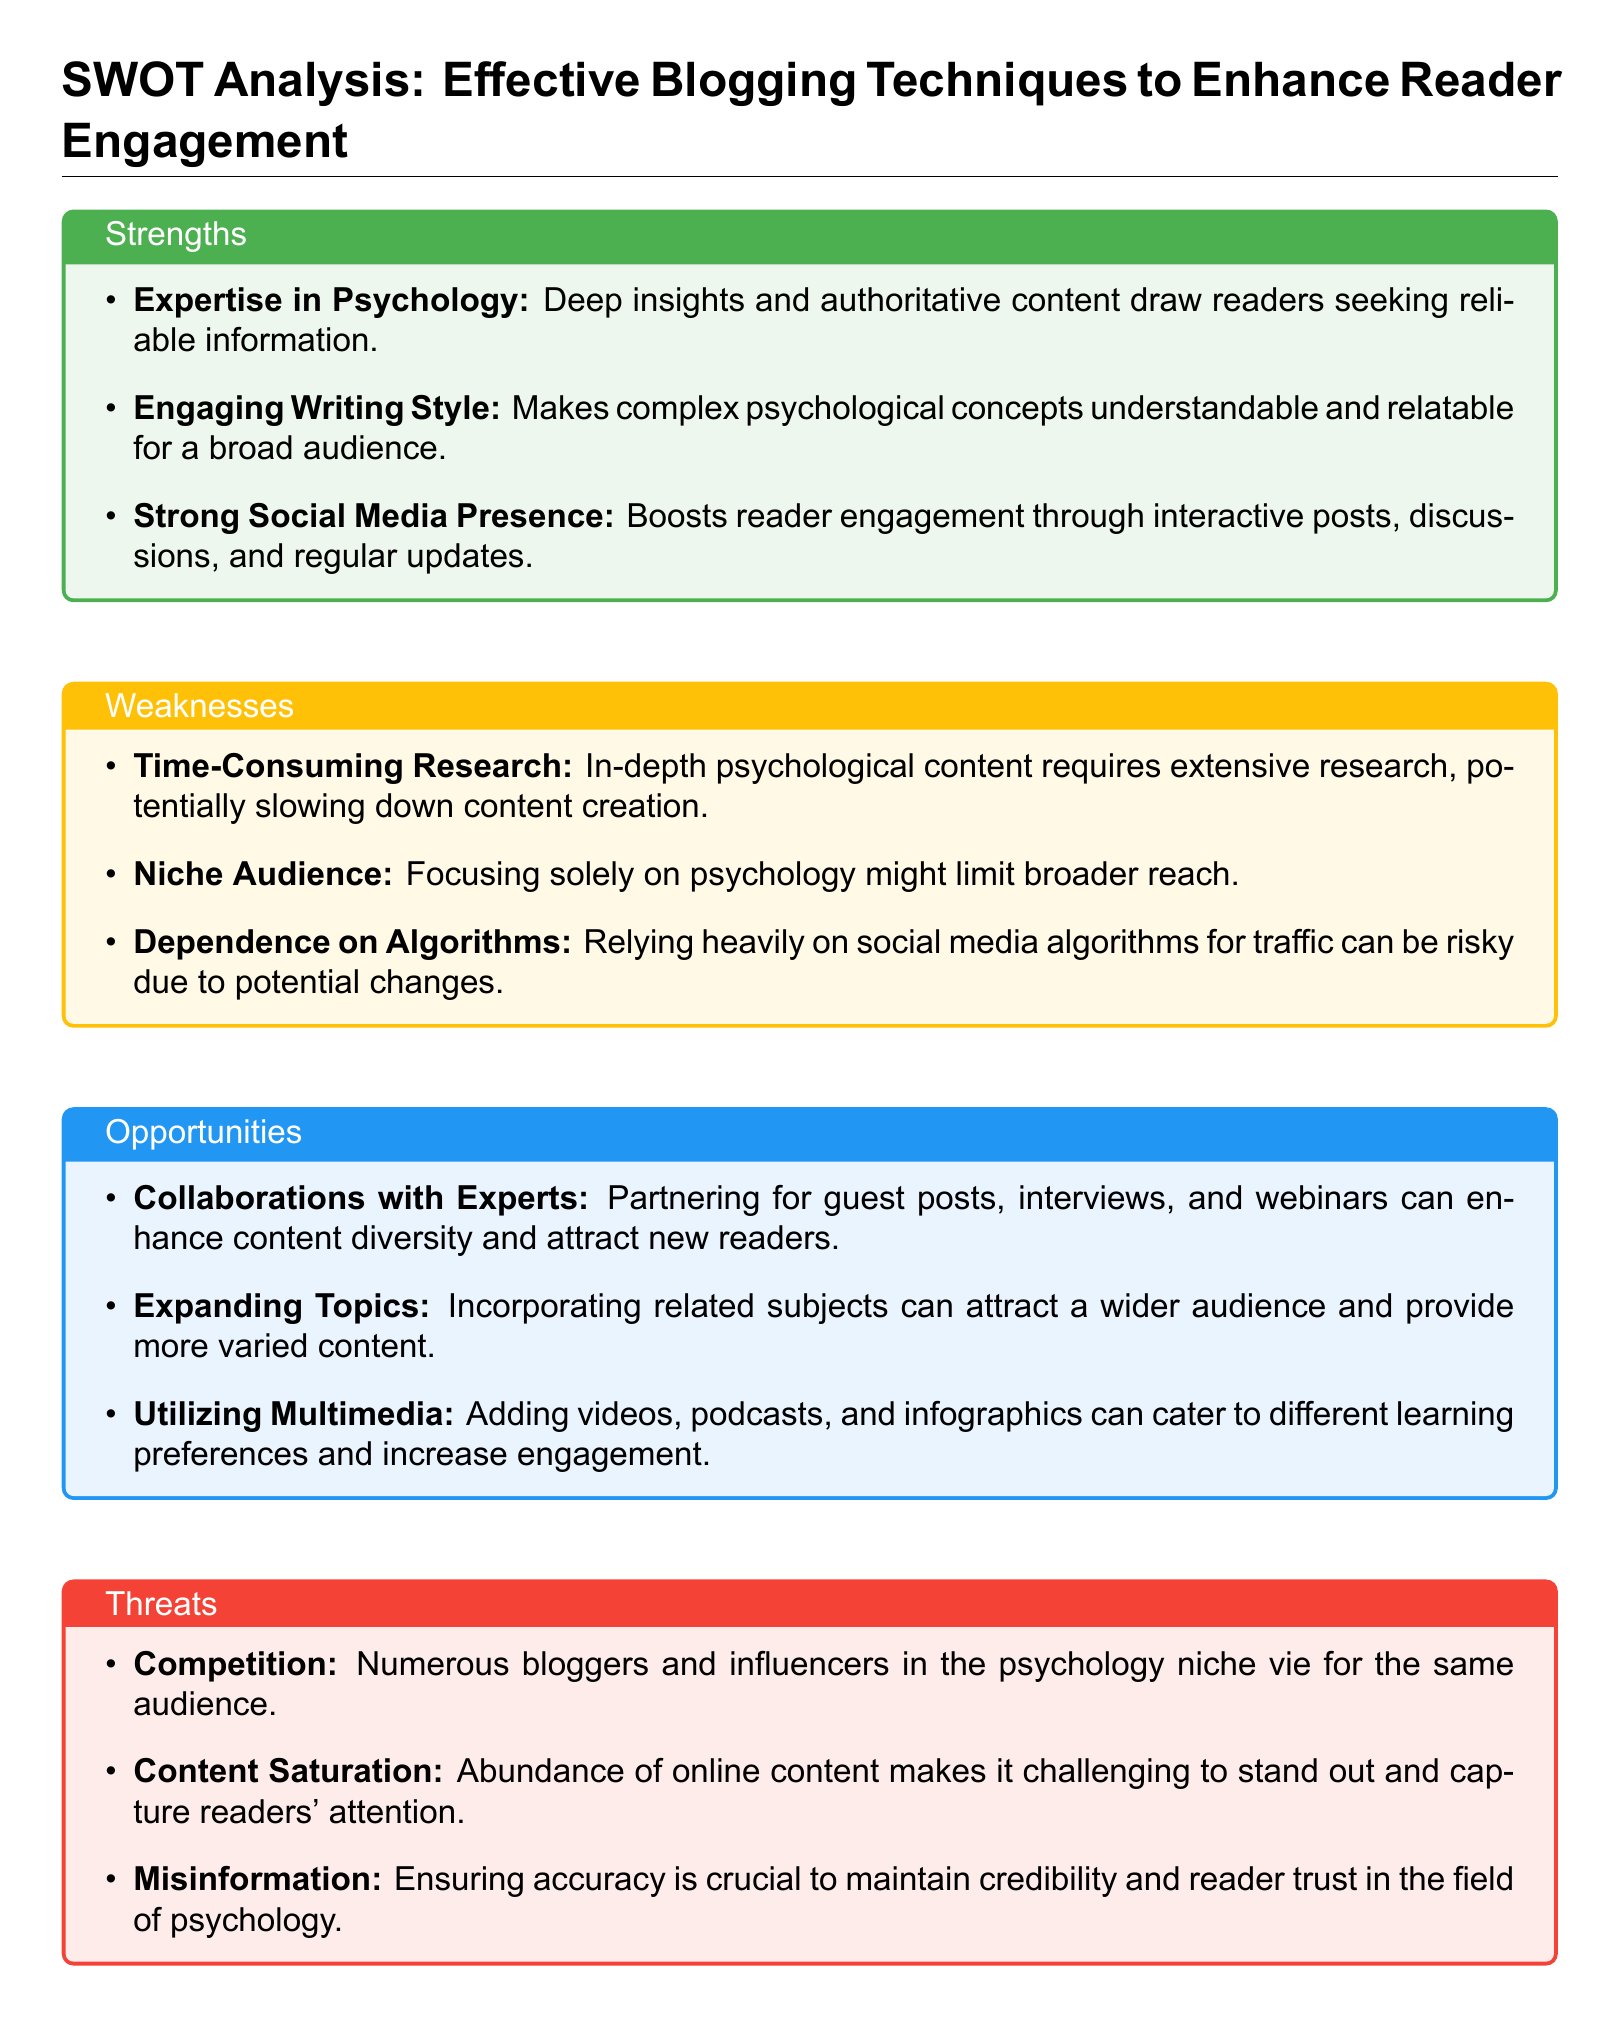What are the strengths highlighted in the document? The strengths are listed in a bullet format within the "Strengths" section of the SWOT analysis.
Answer: Expertise in Psychology, Engaging Writing Style, Strong Social Media Presence What weakness is mentioned that involves research? The weakness specifically refers to the time and effort required for research, affecting content creation.
Answer: Time-Consuming Research What opportunity involves multimedia? The opportunity discusses the potential benefits of using different media types for enhancing engagement.
Answer: Utilizing Multimedia How many threats are identified in the analysis? The document lists three distinct threats under the "Threats" section.
Answer: Three What is a specific risk mentioned related to social media? The document states that relying on social media algorithms poses a risk.
Answer: Dependence on Algorithms Which opportunity can help attract new readers through collaboration? The document suggests partnerships for content enhancement and attracting fresh audience segments.
Answer: Collaborations with Experts What is one characteristic of the writing style mentioned as a strength? The writing style is described in a way that makes psychological concepts understandable.
Answer: Engaging Writing Style What does the document identify as a major challenge for standing out? The challenge is primarily described concerning the abundance of content online.
Answer: Content Saturation 